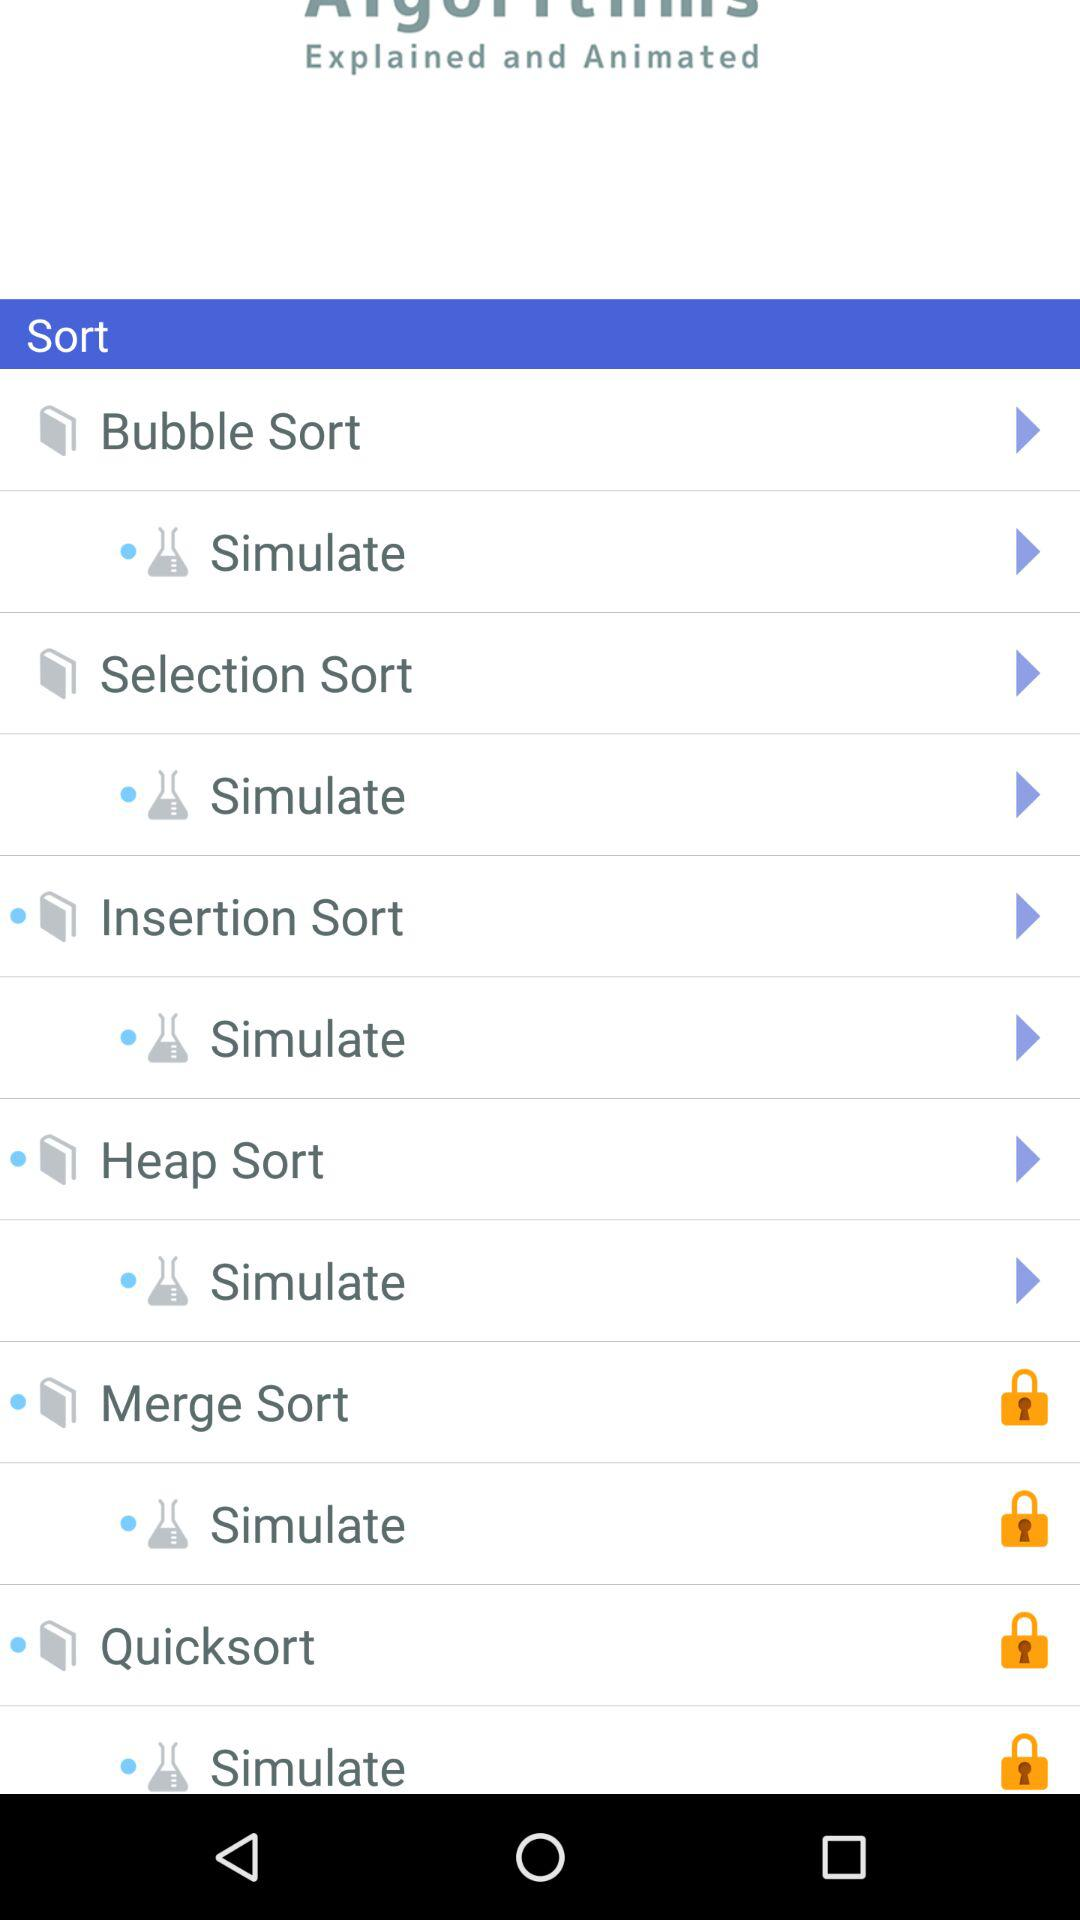Which sorts are locked? The locked sorts are "Merge Sort" and "Quicksort". 